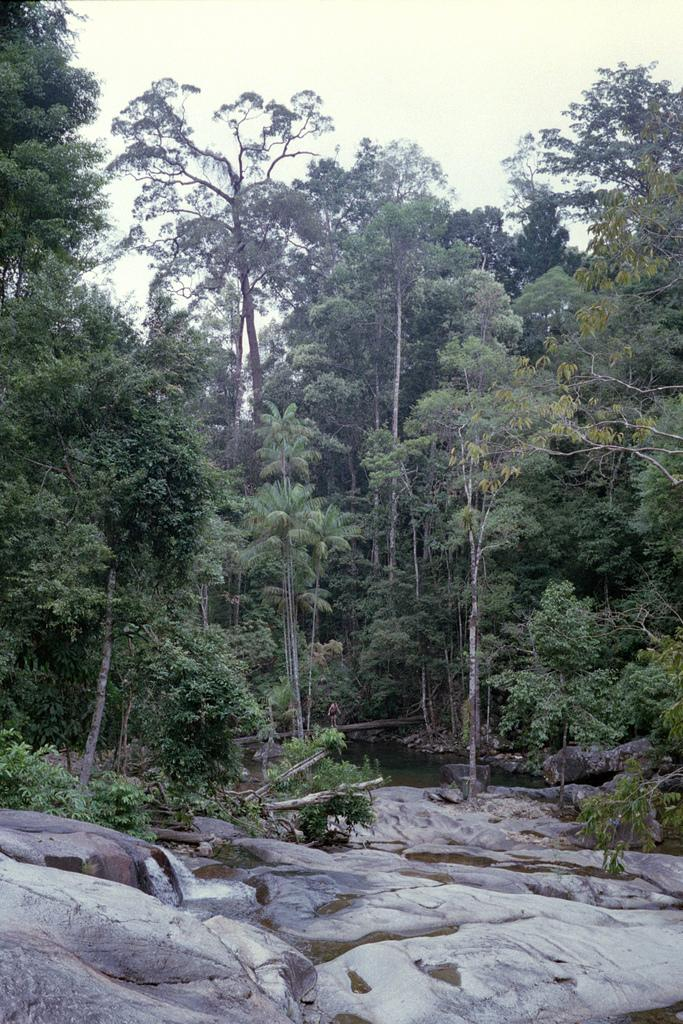What type of vegetation can be seen in the image? There are trees in the image. What part of the natural environment is visible in the image? The sky is visible in the background of the image. What type of bottle is being taxed in the image? There is no bottle or tax-related information present in the image. 